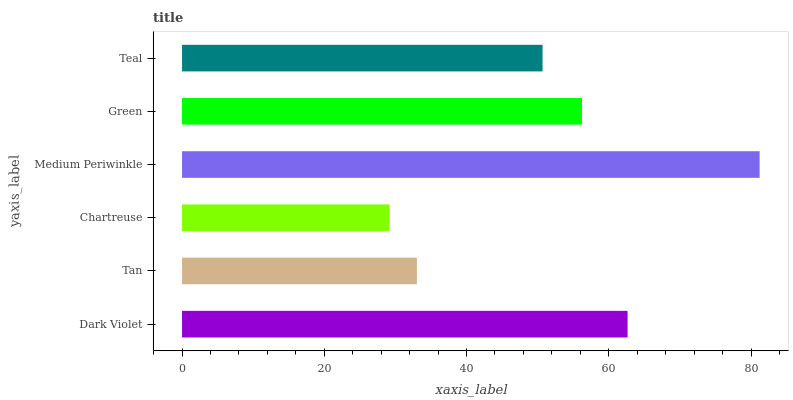Is Chartreuse the minimum?
Answer yes or no. Yes. Is Medium Periwinkle the maximum?
Answer yes or no. Yes. Is Tan the minimum?
Answer yes or no. No. Is Tan the maximum?
Answer yes or no. No. Is Dark Violet greater than Tan?
Answer yes or no. Yes. Is Tan less than Dark Violet?
Answer yes or no. Yes. Is Tan greater than Dark Violet?
Answer yes or no. No. Is Dark Violet less than Tan?
Answer yes or no. No. Is Green the high median?
Answer yes or no. Yes. Is Teal the low median?
Answer yes or no. Yes. Is Chartreuse the high median?
Answer yes or no. No. Is Medium Periwinkle the low median?
Answer yes or no. No. 